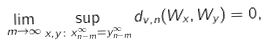<formula> <loc_0><loc_0><loc_500><loc_500>\lim _ { m \to \infty } \sup _ { x , y \colon x _ { n - m } ^ { \infty } = y _ { n - m } ^ { \infty } } d _ { v , n } ( W _ { x } , W _ { y } ) = 0 ,</formula> 